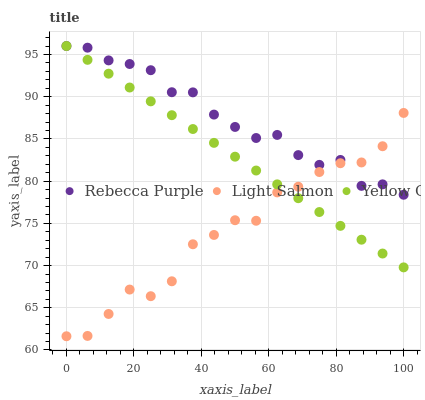Does Light Salmon have the minimum area under the curve?
Answer yes or no. Yes. Does Rebecca Purple have the maximum area under the curve?
Answer yes or no. Yes. Does Yellow Green have the minimum area under the curve?
Answer yes or no. No. Does Yellow Green have the maximum area under the curve?
Answer yes or no. No. Is Yellow Green the smoothest?
Answer yes or no. Yes. Is Light Salmon the roughest?
Answer yes or no. Yes. Is Rebecca Purple the smoothest?
Answer yes or no. No. Is Rebecca Purple the roughest?
Answer yes or no. No. Does Light Salmon have the lowest value?
Answer yes or no. Yes. Does Yellow Green have the lowest value?
Answer yes or no. No. Does Yellow Green have the highest value?
Answer yes or no. Yes. Does Light Salmon intersect Rebecca Purple?
Answer yes or no. Yes. Is Light Salmon less than Rebecca Purple?
Answer yes or no. No. Is Light Salmon greater than Rebecca Purple?
Answer yes or no. No. 